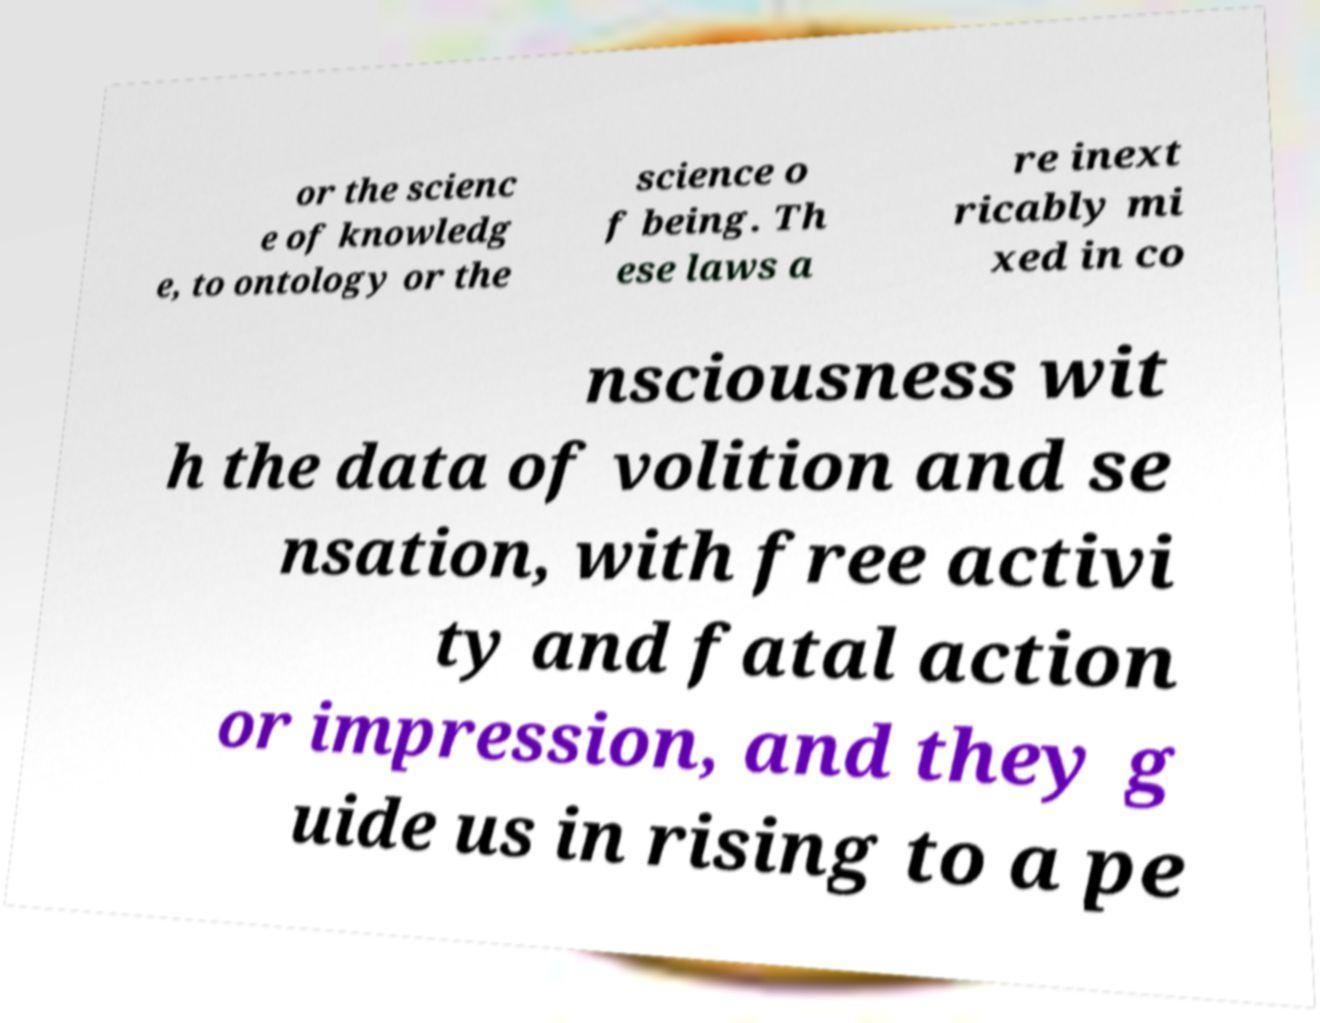Please identify and transcribe the text found in this image. or the scienc e of knowledg e, to ontology or the science o f being. Th ese laws a re inext ricably mi xed in co nsciousness wit h the data of volition and se nsation, with free activi ty and fatal action or impression, and they g uide us in rising to a pe 